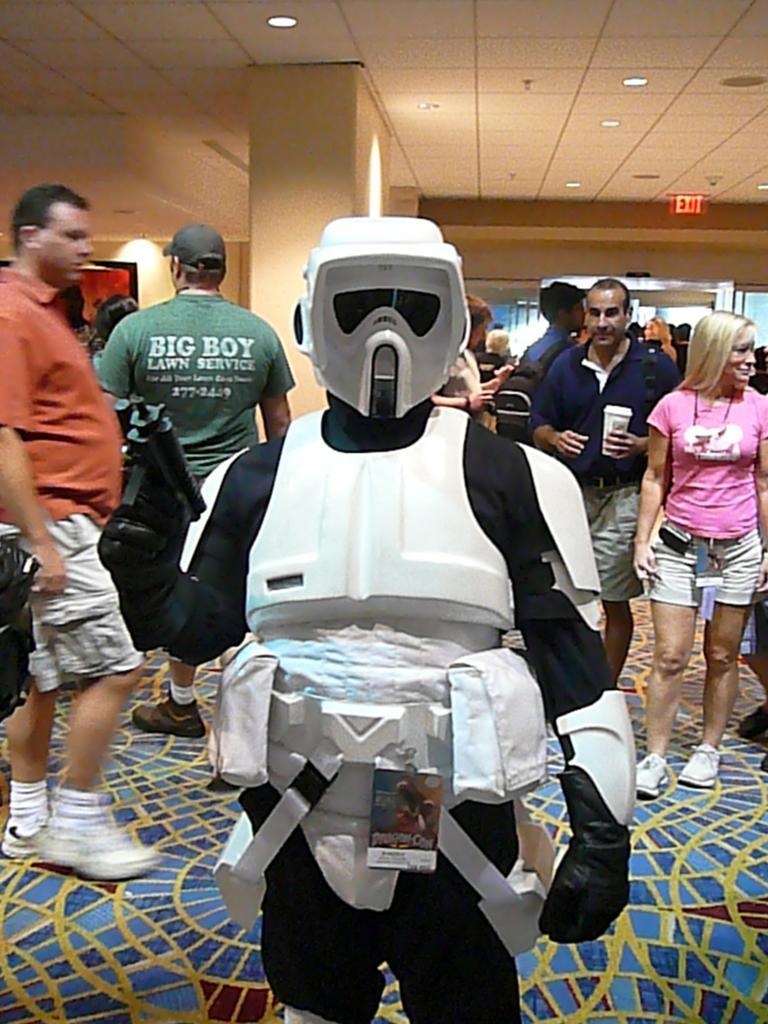In one or two sentences, can you explain what this image depicts? In this picture I can see a person in a costume, there are group of people standing, there are lights and an exit board. 